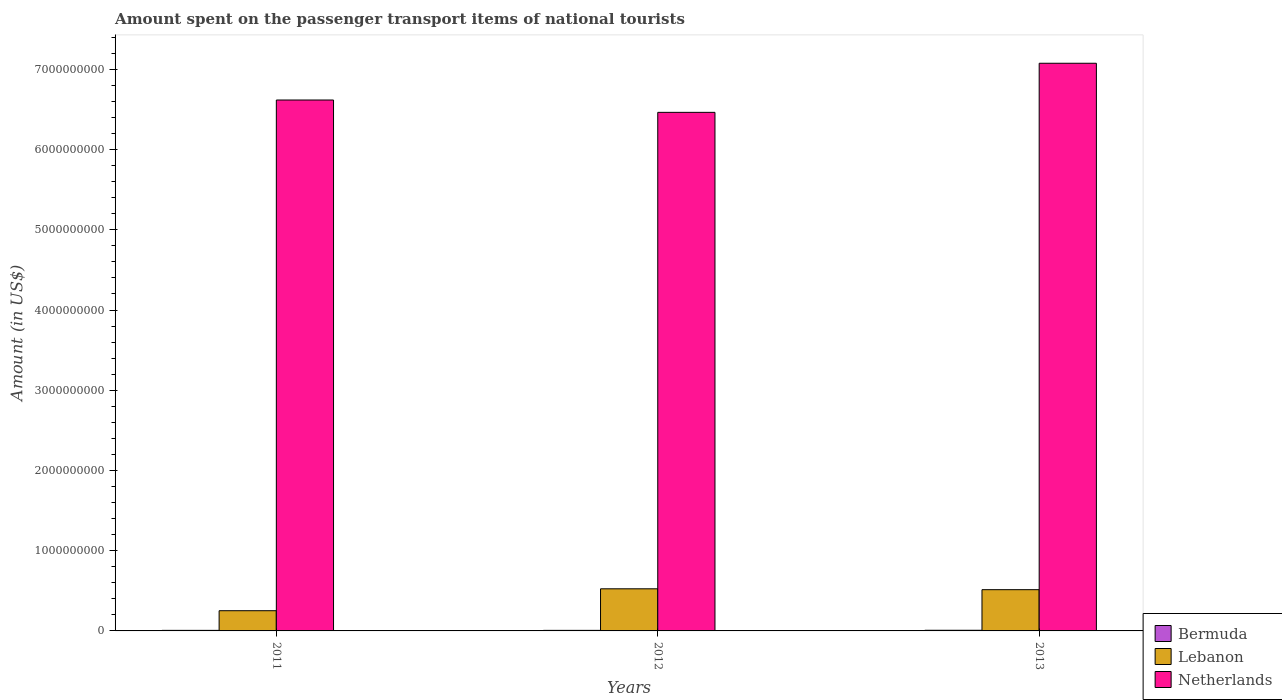Are the number of bars per tick equal to the number of legend labels?
Your answer should be very brief. Yes. What is the label of the 3rd group of bars from the left?
Offer a terse response. 2013. In how many cases, is the number of bars for a given year not equal to the number of legend labels?
Ensure brevity in your answer.  0. What is the amount spent on the passenger transport items of national tourists in Netherlands in 2013?
Your answer should be compact. 7.08e+09. Across all years, what is the maximum amount spent on the passenger transport items of national tourists in Lebanon?
Provide a short and direct response. 5.25e+08. Across all years, what is the minimum amount spent on the passenger transport items of national tourists in Lebanon?
Ensure brevity in your answer.  2.52e+08. In which year was the amount spent on the passenger transport items of national tourists in Netherlands maximum?
Offer a terse response. 2013. What is the total amount spent on the passenger transport items of national tourists in Bermuda in the graph?
Ensure brevity in your answer.  2.20e+07. What is the difference between the amount spent on the passenger transport items of national tourists in Netherlands in 2012 and that in 2013?
Give a very brief answer. -6.12e+08. What is the difference between the amount spent on the passenger transport items of national tourists in Netherlands in 2011 and the amount spent on the passenger transport items of national tourists in Bermuda in 2013?
Give a very brief answer. 6.61e+09. What is the average amount spent on the passenger transport items of national tourists in Lebanon per year?
Ensure brevity in your answer.  4.30e+08. In the year 2012, what is the difference between the amount spent on the passenger transport items of national tourists in Lebanon and amount spent on the passenger transport items of national tourists in Netherlands?
Provide a short and direct response. -5.94e+09. In how many years, is the amount spent on the passenger transport items of national tourists in Bermuda greater than 5200000000 US$?
Offer a very short reply. 0. What is the ratio of the amount spent on the passenger transport items of national tourists in Lebanon in 2012 to that in 2013?
Provide a succinct answer. 1.02. Is the amount spent on the passenger transport items of national tourists in Netherlands in 2012 less than that in 2013?
Offer a very short reply. Yes. Is the difference between the amount spent on the passenger transport items of national tourists in Lebanon in 2011 and 2012 greater than the difference between the amount spent on the passenger transport items of national tourists in Netherlands in 2011 and 2012?
Ensure brevity in your answer.  No. What is the difference between the highest and the second highest amount spent on the passenger transport items of national tourists in Lebanon?
Make the answer very short. 1.10e+07. What is the difference between the highest and the lowest amount spent on the passenger transport items of national tourists in Lebanon?
Offer a terse response. 2.73e+08. In how many years, is the amount spent on the passenger transport items of national tourists in Bermuda greater than the average amount spent on the passenger transport items of national tourists in Bermuda taken over all years?
Provide a succinct answer. 1. Is the sum of the amount spent on the passenger transport items of national tourists in Lebanon in 2011 and 2013 greater than the maximum amount spent on the passenger transport items of national tourists in Netherlands across all years?
Give a very brief answer. No. What does the 2nd bar from the left in 2013 represents?
Provide a short and direct response. Lebanon. What does the 2nd bar from the right in 2012 represents?
Offer a very short reply. Lebanon. Is it the case that in every year, the sum of the amount spent on the passenger transport items of national tourists in Lebanon and amount spent on the passenger transport items of national tourists in Bermuda is greater than the amount spent on the passenger transport items of national tourists in Netherlands?
Offer a terse response. No. How many bars are there?
Ensure brevity in your answer.  9. What is the difference between two consecutive major ticks on the Y-axis?
Provide a succinct answer. 1.00e+09. How many legend labels are there?
Provide a short and direct response. 3. How are the legend labels stacked?
Offer a very short reply. Vertical. What is the title of the graph?
Make the answer very short. Amount spent on the passenger transport items of national tourists. What is the label or title of the Y-axis?
Ensure brevity in your answer.  Amount (in US$). What is the Amount (in US$) in Lebanon in 2011?
Give a very brief answer. 2.52e+08. What is the Amount (in US$) of Netherlands in 2011?
Give a very brief answer. 6.62e+09. What is the Amount (in US$) of Bermuda in 2012?
Offer a terse response. 7.00e+06. What is the Amount (in US$) in Lebanon in 2012?
Offer a terse response. 5.25e+08. What is the Amount (in US$) of Netherlands in 2012?
Provide a short and direct response. 6.46e+09. What is the Amount (in US$) of Bermuda in 2013?
Ensure brevity in your answer.  8.00e+06. What is the Amount (in US$) of Lebanon in 2013?
Give a very brief answer. 5.14e+08. What is the Amount (in US$) in Netherlands in 2013?
Your answer should be compact. 7.08e+09. Across all years, what is the maximum Amount (in US$) in Lebanon?
Your response must be concise. 5.25e+08. Across all years, what is the maximum Amount (in US$) in Netherlands?
Offer a very short reply. 7.08e+09. Across all years, what is the minimum Amount (in US$) in Lebanon?
Offer a terse response. 2.52e+08. Across all years, what is the minimum Amount (in US$) of Netherlands?
Keep it short and to the point. 6.46e+09. What is the total Amount (in US$) of Bermuda in the graph?
Offer a very short reply. 2.20e+07. What is the total Amount (in US$) of Lebanon in the graph?
Your response must be concise. 1.29e+09. What is the total Amount (in US$) of Netherlands in the graph?
Offer a terse response. 2.02e+1. What is the difference between the Amount (in US$) in Bermuda in 2011 and that in 2012?
Offer a very short reply. 0. What is the difference between the Amount (in US$) in Lebanon in 2011 and that in 2012?
Your answer should be very brief. -2.73e+08. What is the difference between the Amount (in US$) of Netherlands in 2011 and that in 2012?
Make the answer very short. 1.54e+08. What is the difference between the Amount (in US$) in Bermuda in 2011 and that in 2013?
Your response must be concise. -1.00e+06. What is the difference between the Amount (in US$) in Lebanon in 2011 and that in 2013?
Offer a very short reply. -2.62e+08. What is the difference between the Amount (in US$) of Netherlands in 2011 and that in 2013?
Offer a very short reply. -4.58e+08. What is the difference between the Amount (in US$) in Lebanon in 2012 and that in 2013?
Make the answer very short. 1.10e+07. What is the difference between the Amount (in US$) in Netherlands in 2012 and that in 2013?
Your response must be concise. -6.12e+08. What is the difference between the Amount (in US$) of Bermuda in 2011 and the Amount (in US$) of Lebanon in 2012?
Provide a short and direct response. -5.18e+08. What is the difference between the Amount (in US$) of Bermuda in 2011 and the Amount (in US$) of Netherlands in 2012?
Provide a succinct answer. -6.46e+09. What is the difference between the Amount (in US$) in Lebanon in 2011 and the Amount (in US$) in Netherlands in 2012?
Provide a short and direct response. -6.21e+09. What is the difference between the Amount (in US$) of Bermuda in 2011 and the Amount (in US$) of Lebanon in 2013?
Provide a short and direct response. -5.07e+08. What is the difference between the Amount (in US$) of Bermuda in 2011 and the Amount (in US$) of Netherlands in 2013?
Offer a terse response. -7.07e+09. What is the difference between the Amount (in US$) in Lebanon in 2011 and the Amount (in US$) in Netherlands in 2013?
Provide a short and direct response. -6.82e+09. What is the difference between the Amount (in US$) of Bermuda in 2012 and the Amount (in US$) of Lebanon in 2013?
Offer a very short reply. -5.07e+08. What is the difference between the Amount (in US$) in Bermuda in 2012 and the Amount (in US$) in Netherlands in 2013?
Give a very brief answer. -7.07e+09. What is the difference between the Amount (in US$) in Lebanon in 2012 and the Amount (in US$) in Netherlands in 2013?
Offer a very short reply. -6.55e+09. What is the average Amount (in US$) in Bermuda per year?
Offer a terse response. 7.33e+06. What is the average Amount (in US$) of Lebanon per year?
Your response must be concise. 4.30e+08. What is the average Amount (in US$) of Netherlands per year?
Keep it short and to the point. 6.72e+09. In the year 2011, what is the difference between the Amount (in US$) in Bermuda and Amount (in US$) in Lebanon?
Make the answer very short. -2.45e+08. In the year 2011, what is the difference between the Amount (in US$) of Bermuda and Amount (in US$) of Netherlands?
Keep it short and to the point. -6.61e+09. In the year 2011, what is the difference between the Amount (in US$) of Lebanon and Amount (in US$) of Netherlands?
Offer a terse response. -6.37e+09. In the year 2012, what is the difference between the Amount (in US$) of Bermuda and Amount (in US$) of Lebanon?
Keep it short and to the point. -5.18e+08. In the year 2012, what is the difference between the Amount (in US$) in Bermuda and Amount (in US$) in Netherlands?
Provide a succinct answer. -6.46e+09. In the year 2012, what is the difference between the Amount (in US$) in Lebanon and Amount (in US$) in Netherlands?
Your response must be concise. -5.94e+09. In the year 2013, what is the difference between the Amount (in US$) in Bermuda and Amount (in US$) in Lebanon?
Your response must be concise. -5.06e+08. In the year 2013, what is the difference between the Amount (in US$) in Bermuda and Amount (in US$) in Netherlands?
Provide a succinct answer. -7.07e+09. In the year 2013, what is the difference between the Amount (in US$) of Lebanon and Amount (in US$) of Netherlands?
Give a very brief answer. -6.56e+09. What is the ratio of the Amount (in US$) in Lebanon in 2011 to that in 2012?
Give a very brief answer. 0.48. What is the ratio of the Amount (in US$) in Netherlands in 2011 to that in 2012?
Provide a short and direct response. 1.02. What is the ratio of the Amount (in US$) of Lebanon in 2011 to that in 2013?
Give a very brief answer. 0.49. What is the ratio of the Amount (in US$) of Netherlands in 2011 to that in 2013?
Offer a very short reply. 0.94. What is the ratio of the Amount (in US$) of Bermuda in 2012 to that in 2013?
Offer a very short reply. 0.88. What is the ratio of the Amount (in US$) of Lebanon in 2012 to that in 2013?
Offer a very short reply. 1.02. What is the ratio of the Amount (in US$) of Netherlands in 2012 to that in 2013?
Your answer should be very brief. 0.91. What is the difference between the highest and the second highest Amount (in US$) in Bermuda?
Provide a short and direct response. 1.00e+06. What is the difference between the highest and the second highest Amount (in US$) in Lebanon?
Your answer should be very brief. 1.10e+07. What is the difference between the highest and the second highest Amount (in US$) of Netherlands?
Your answer should be very brief. 4.58e+08. What is the difference between the highest and the lowest Amount (in US$) in Lebanon?
Keep it short and to the point. 2.73e+08. What is the difference between the highest and the lowest Amount (in US$) of Netherlands?
Provide a succinct answer. 6.12e+08. 